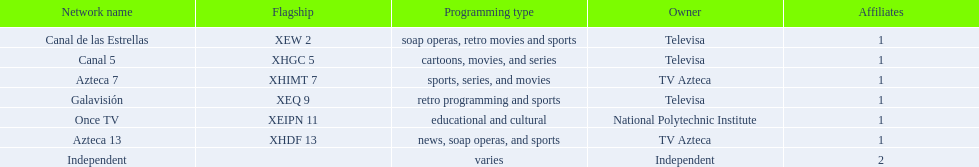What station shows cartoons? Canal 5. What station shows soap operas? Canal de las Estrellas. Could you parse the entire table? {'header': ['Network name', 'Flagship', 'Programming type', 'Owner', 'Affiliates'], 'rows': [['Canal de las Estrellas', 'XEW 2', 'soap operas, retro movies and sports', 'Televisa', '1'], ['Canal 5', 'XHGC 5', 'cartoons, movies, and series', 'Televisa', '1'], ['Azteca 7', 'XHIMT 7', 'sports, series, and movies', 'TV Azteca', '1'], ['Galavisión', 'XEQ 9', 'retro programming and sports', 'Televisa', '1'], ['Once TV', 'XEIPN 11', 'educational and cultural', 'National Polytechnic Institute', '1'], ['Azteca 13', 'XHDF 13', 'news, soap operas, and sports', 'TV Azteca', '1'], ['Independent', '', 'varies', 'Independent', '2']]} What station shows sports? Azteca 7. 